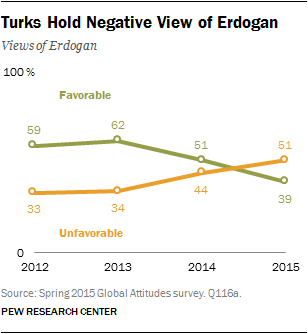Outline some significant characteristics in this image. The average of the orange graph from 2012 to 2014 is approximately 37. There are two colored lines present. 